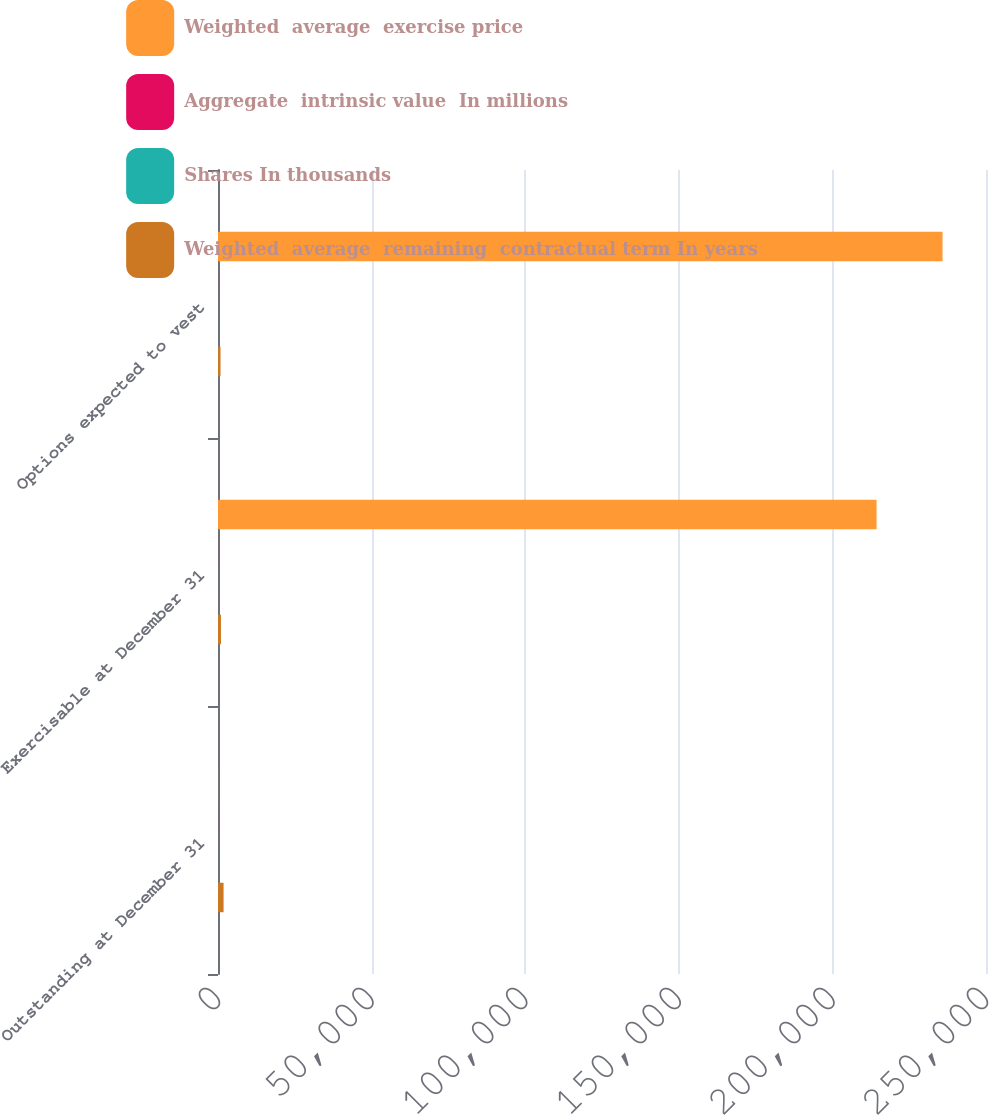<chart> <loc_0><loc_0><loc_500><loc_500><stacked_bar_chart><ecel><fcel>Outstanding at December 31<fcel>Exercisable at December 31<fcel>Options expected to vest<nl><fcel>Weighted  average  exercise price<fcel>20.85<fcel>214377<fcel>235849<nl><fcel>Aggregate  intrinsic value  In millions<fcel>19.27<fcel>20.85<fcel>17.82<nl><fcel>Shares In thousands<fcel>6.9<fcel>5.3<fcel>8.2<nl><fcel>Weighted  average  remaining  contractual term In years<fcel>1810<fcel>964<fcel>814<nl></chart> 